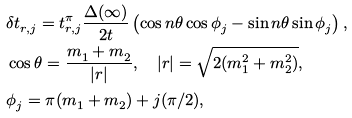Convert formula to latex. <formula><loc_0><loc_0><loc_500><loc_500>& \delta t ^ { \ } _ { r , j } = t ^ { \pi } _ { r , j } \frac { \Delta ( \infty ) } { 2 t } \left ( \cos n \theta \cos \phi ^ { \ } _ { j } - \sin n \theta \sin \phi ^ { \ } _ { j } \right ) , \\ & \cos \theta = \frac { m ^ { \ } _ { 1 } + m ^ { \ } _ { 2 } } { | r | } , \quad | r | = \sqrt { 2 ( m ^ { 2 } _ { 1 } + m ^ { 2 } _ { 2 } ) } , \\ & \phi ^ { \ } _ { j } = \pi ( m ^ { \ } _ { 1 } + m ^ { \ } _ { 2 } ) + j ( \pi / 2 ) ,</formula> 